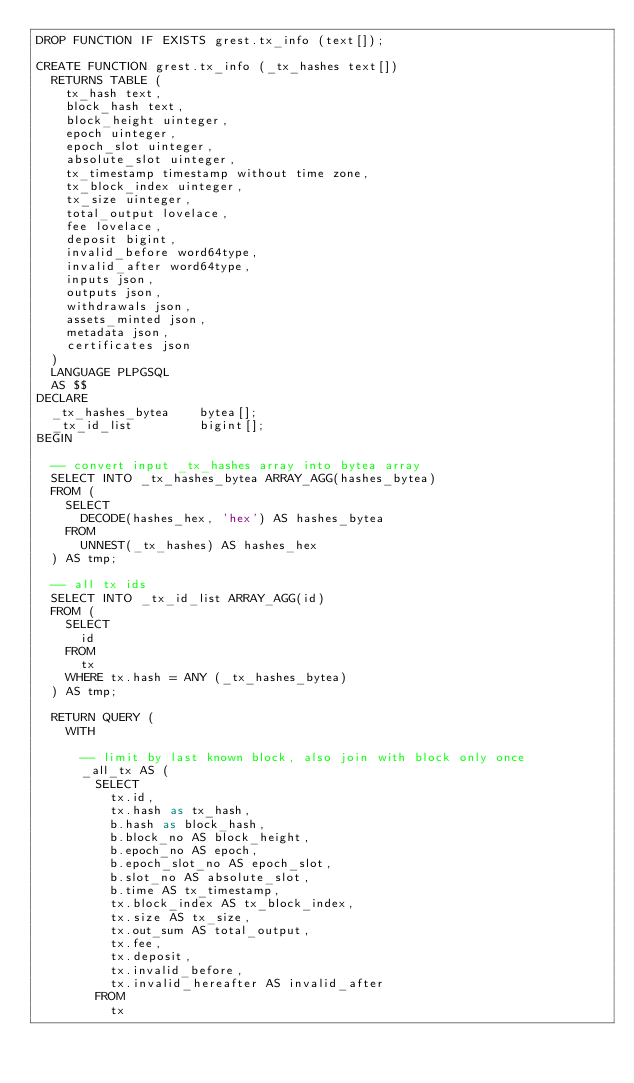<code> <loc_0><loc_0><loc_500><loc_500><_SQL_>DROP FUNCTION IF EXISTS grest.tx_info (text[]);

CREATE FUNCTION grest.tx_info (_tx_hashes text[])
  RETURNS TABLE (
    tx_hash text,
    block_hash text,
    block_height uinteger,
    epoch uinteger,
    epoch_slot uinteger,
    absolute_slot uinteger,
    tx_timestamp timestamp without time zone,
    tx_block_index uinteger,
    tx_size uinteger,
    total_output lovelace,
    fee lovelace,
    deposit bigint,
    invalid_before word64type,
    invalid_after word64type,
    inputs json,
    outputs json,
    withdrawals json,
    assets_minted json,
    metadata json,
    certificates json
  )
  LANGUAGE PLPGSQL
  AS $$
DECLARE
  _tx_hashes_bytea    bytea[];
  _tx_id_list         bigint[];
BEGIN

  -- convert input _tx_hashes array into bytea array
  SELECT INTO _tx_hashes_bytea ARRAY_AGG(hashes_bytea)
  FROM (
    SELECT
      DECODE(hashes_hex, 'hex') AS hashes_bytea
    FROM
      UNNEST(_tx_hashes) AS hashes_hex
  ) AS tmp;

  -- all tx ids
  SELECT INTO _tx_id_list ARRAY_AGG(id)
  FROM (
    SELECT
      id
    FROM 
      tx
    WHERE tx.hash = ANY (_tx_hashes_bytea)
  ) AS tmp;

  RETURN QUERY (
    WITH

      -- limit by last known block, also join with block only once
      _all_tx AS (
        SELECT
          tx.id,
          tx.hash as tx_hash,
          b.hash as block_hash,
          b.block_no AS block_height,
          b.epoch_no AS epoch,
          b.epoch_slot_no AS epoch_slot,
          b.slot_no AS absolute_slot,
          b.time AS tx_timestamp,
          tx.block_index AS tx_block_index,
          tx.size AS tx_size,
          tx.out_sum AS total_output,
          tx.fee,
          tx.deposit,
          tx.invalid_before,
          tx.invalid_hereafter AS invalid_after
        FROM
          tx</code> 